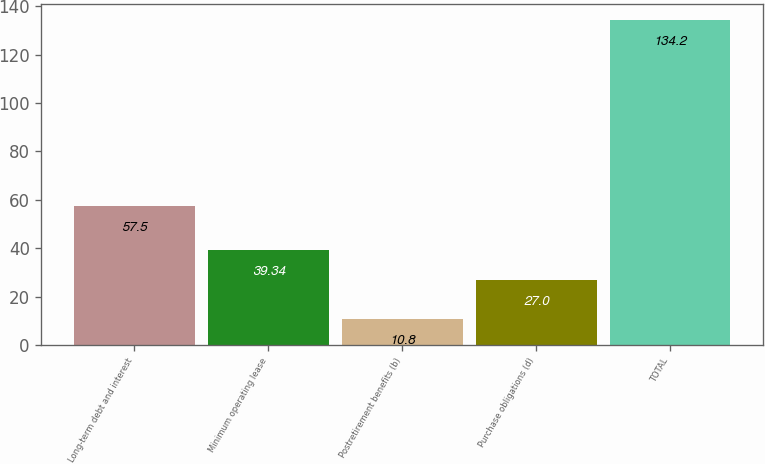<chart> <loc_0><loc_0><loc_500><loc_500><bar_chart><fcel>Long-term debt and interest<fcel>Minimum operating lease<fcel>Postretirement benefits (b)<fcel>Purchase obligations (d)<fcel>TOTAL<nl><fcel>57.5<fcel>39.34<fcel>10.8<fcel>27<fcel>134.2<nl></chart> 